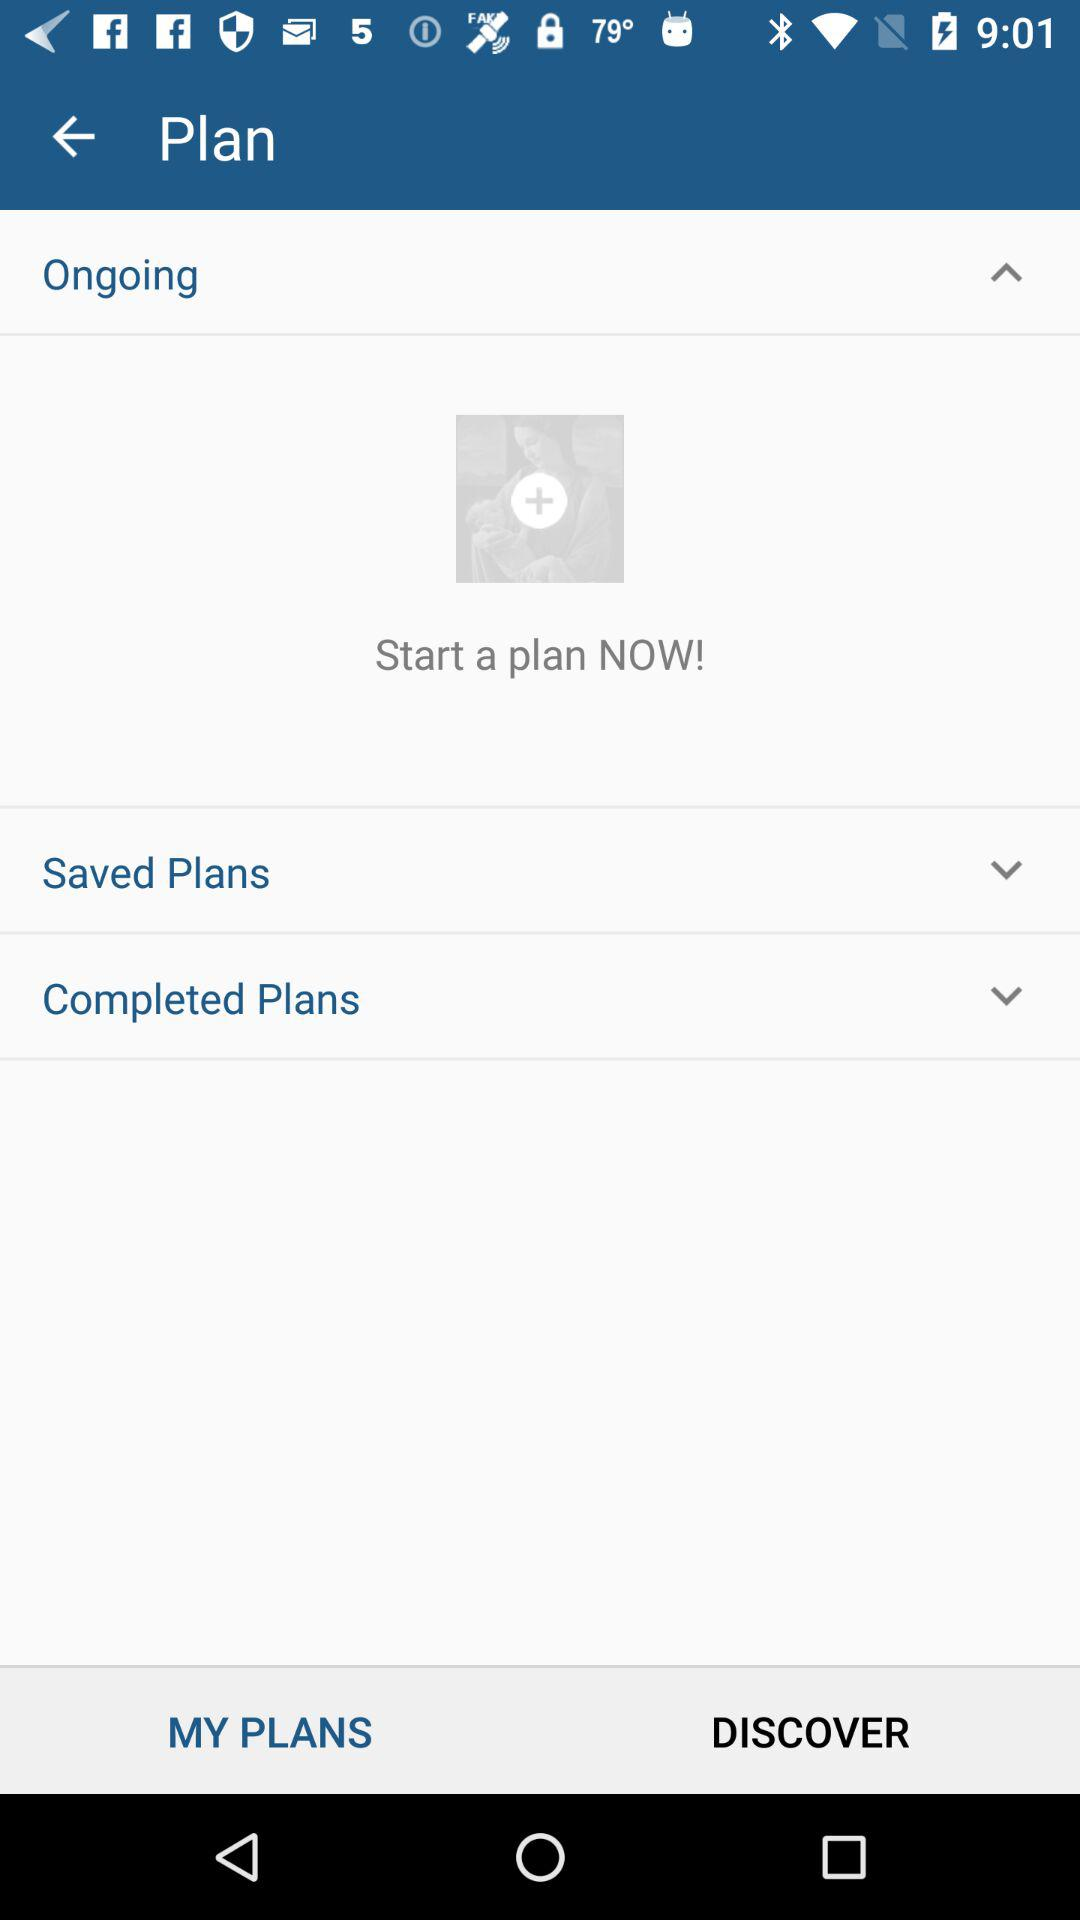How many sections are there on the page?
Answer the question using a single word or phrase. 3 